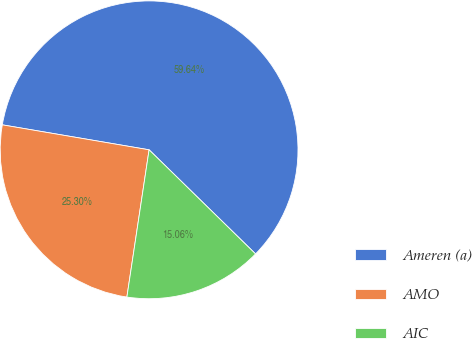Convert chart to OTSL. <chart><loc_0><loc_0><loc_500><loc_500><pie_chart><fcel>Ameren (a)<fcel>AMO<fcel>AIC<nl><fcel>59.64%<fcel>25.3%<fcel>15.06%<nl></chart> 